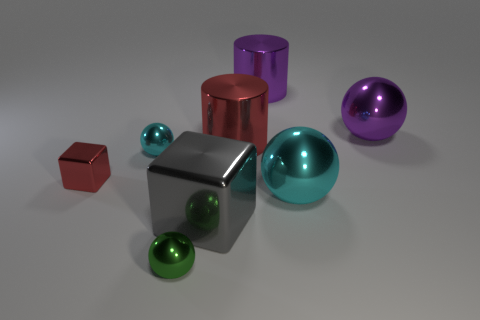What number of other things are the same size as the red metallic block?
Keep it short and to the point. 2. Does the small green thing have the same material as the cyan ball that is on the right side of the gray thing?
Make the answer very short. Yes. How many objects are either purple metal things that are right of the large purple metallic cylinder or cyan shiny things in front of the tiny cube?
Offer a terse response. 2. The large metallic block has what color?
Provide a succinct answer. Gray. Are there fewer small red cubes right of the gray metal block than balls?
Your answer should be very brief. Yes. Is there anything else that has the same shape as the small red shiny object?
Give a very brief answer. Yes. Are there any purple cylinders?
Your response must be concise. Yes. Is the number of purple objects less than the number of metal objects?
Make the answer very short. Yes. What number of other cubes are the same material as the tiny red block?
Keep it short and to the point. 1. There is a tiny cube that is made of the same material as the big block; what is its color?
Give a very brief answer. Red. 